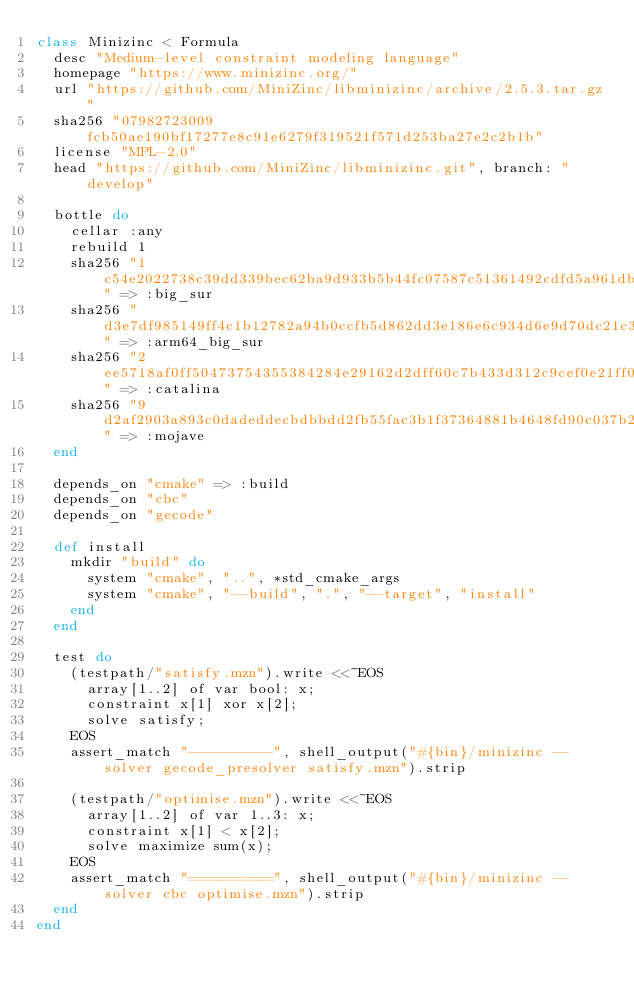<code> <loc_0><loc_0><loc_500><loc_500><_Ruby_>class Minizinc < Formula
  desc "Medium-level constraint modeling language"
  homepage "https://www.minizinc.org/"
  url "https://github.com/MiniZinc/libminizinc/archive/2.5.3.tar.gz"
  sha256 "07982723009fcb50ae190bf17277e8c91e6279f319521f571d253ba27e2c2b1b"
  license "MPL-2.0"
  head "https://github.com/MiniZinc/libminizinc.git", branch: "develop"

  bottle do
    cellar :any
    rebuild 1
    sha256 "1c54e2022738c39dd339bec62ba9d933b5b44fc07587c51361492cdfd5a961db" => :big_sur
    sha256 "d3e7df985149ff4c1b12782a94b0ccfb5d862dd3e186e6c934d6e9d70dc21c3e" => :arm64_big_sur
    sha256 "2ee5718af0ff50473754355384284e29162d2dff60c7b433d312c9cef0e21ff0" => :catalina
    sha256 "9d2af2903a893c0dadeddecbdbbdd2fb55fac3b1f37364881b4648fd90c037b2" => :mojave
  end

  depends_on "cmake" => :build
  depends_on "cbc"
  depends_on "gecode"

  def install
    mkdir "build" do
      system "cmake", "..", *std_cmake_args
      system "cmake", "--build", ".", "--target", "install"
    end
  end

  test do
    (testpath/"satisfy.mzn").write <<~EOS
      array[1..2] of var bool: x;
      constraint x[1] xor x[2];
      solve satisfy;
    EOS
    assert_match "----------", shell_output("#{bin}/minizinc --solver gecode_presolver satisfy.mzn").strip

    (testpath/"optimise.mzn").write <<~EOS
      array[1..2] of var 1..3: x;
      constraint x[1] < x[2];
      solve maximize sum(x);
    EOS
    assert_match "==========", shell_output("#{bin}/minizinc --solver cbc optimise.mzn").strip
  end
end
</code> 